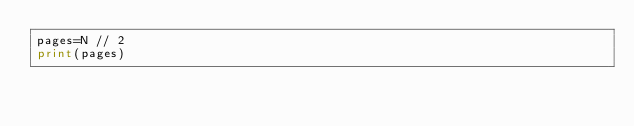<code> <loc_0><loc_0><loc_500><loc_500><_Python_>pages=N // 2
print(pages)</code> 